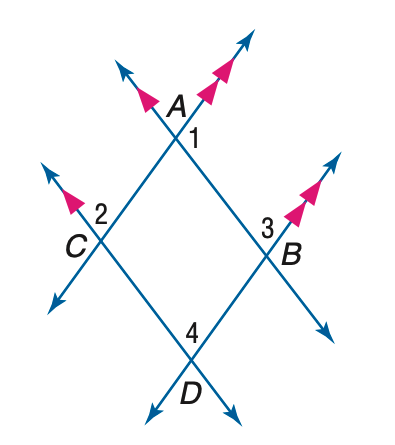Answer the mathemtical geometry problem and directly provide the correct option letter.
Question: In the figure, m \angle 1 = 4 p + 15, m \angle 3 = 3 p - 10 and m \angle 4 = 6 r + 5. Find the value of r.
Choices: A: 10 B: 15 C: 20 D: 25 A 